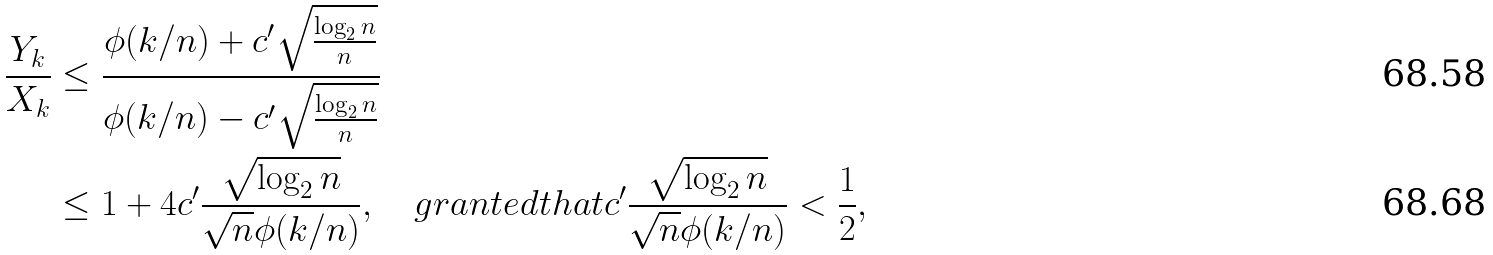Convert formula to latex. <formula><loc_0><loc_0><loc_500><loc_500>\frac { Y _ { k } } { X _ { k } } & \leq \frac { \phi ( k / n ) + c ^ { \prime } \sqrt { \frac { \log _ { 2 } n } { n } } } { \phi ( k / n ) - c ^ { \prime } \sqrt { \frac { \log _ { 2 } n } { n } } } \\ & \leq 1 + 4 c ^ { \prime } \frac { \sqrt { \log _ { 2 } n } } { \sqrt { n } \phi ( k / n ) } , \quad g r a n t e d t h a t c ^ { \prime } \frac { \sqrt { \log _ { 2 } n } } { \sqrt { n } \phi ( k / n ) } < \frac { 1 } { 2 } ,</formula> 